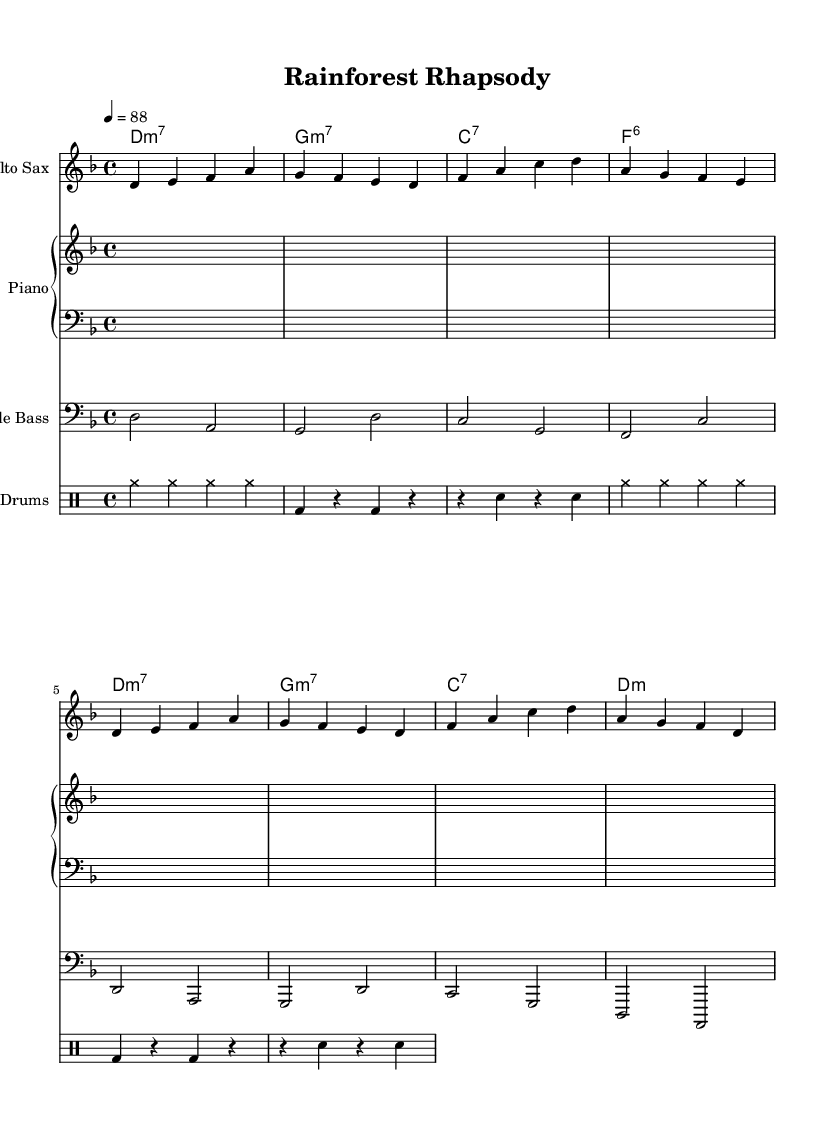What is the key signature of this music? The key signature is D minor, which has one flat (the B). This is identified by looking for any sharps or flats indicated at the beginning of the staff.
Answer: D minor What is the time signature of this piece? The time signature is 4/4. This can be seen at the beginning of the staff, indicating that there are four beats in each measure and a quarter note receives one beat.
Answer: 4/4 What is the tempo marking for this piece? The tempo marking is 88 beats per minute, indicated by the number under the tempo indication at the start of the piece.
Answer: 88 How many measures are in the piece? There are 16 measures in total. This can be counted by noting the vertical bar lines that indicate the end of each measure.
Answer: 16 What type of jazz is represented by this piece? This piece represents cool jazz, characterized by a relaxed tempo and softer tone quality. This can be inferred from the style and overall feel of the music as described in the context.
Answer: Cool jazz What is the main instrument featured in this composition? The main instrument featured is the Alto Saxophone, which is indicated as the first staff in the score along with its specific part notation.
Answer: Alto Saxophone What is the chord progression used in the piano part? The chord progression is D minor 7, G minor 7, C 7, F 6. This is determined by examining the chord symbols written above the staff for the piano part.
Answer: D minor 7, G minor 7, C 7, F 6 